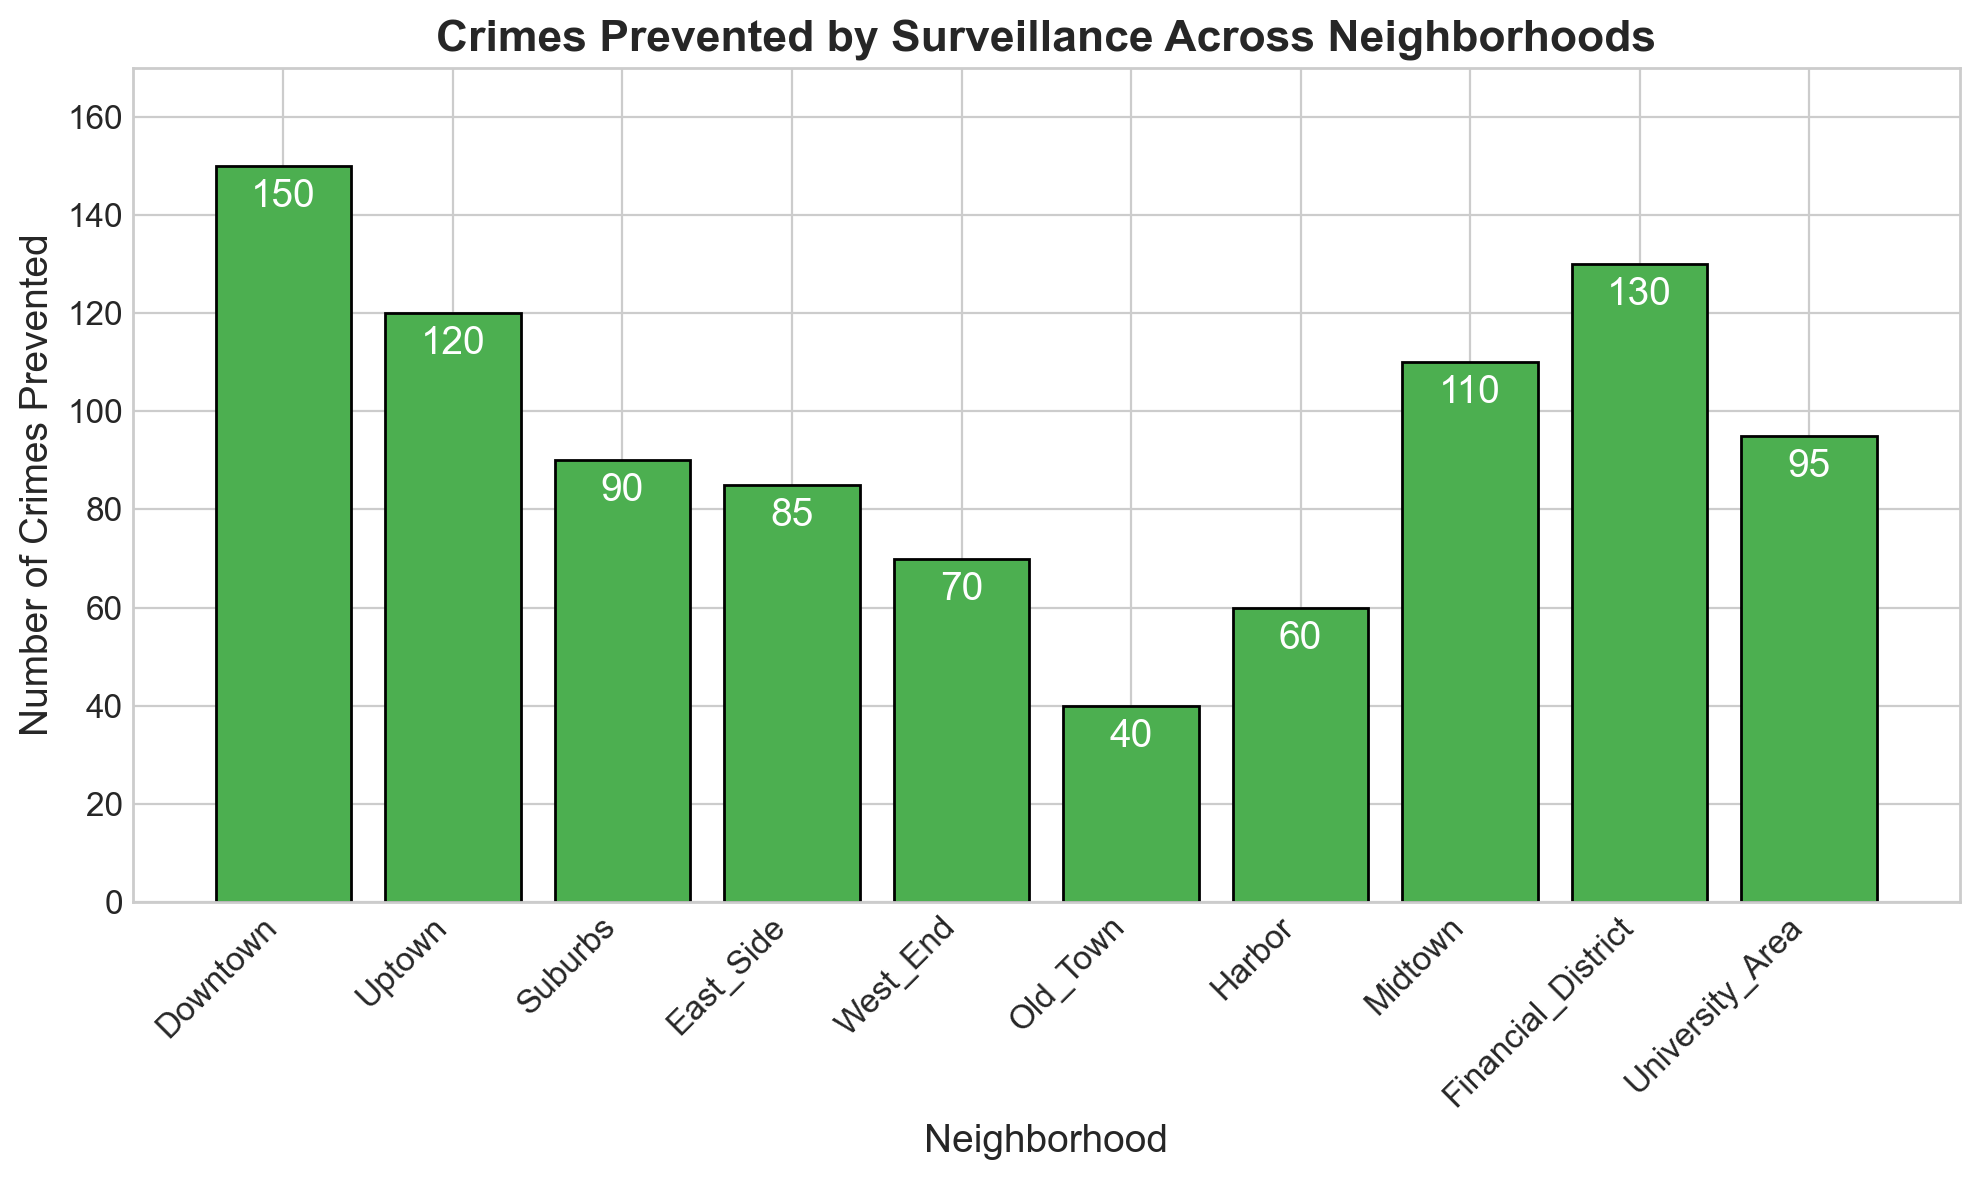What's the neighborhood with the highest number of crimes prevented? Look at the bar with the greatest height. The "Downtown" bar is the tallest, indicating the highest number of crimes prevented.
Answer: Downtown Which neighborhood prevented fewer crimes than the University Area but more than East Side? Identify the bars for University Area and East Side. University Area is 95, East Side is 85. Find bars between these values: Suburbs with 90 fits this range.
Answer: Suburbs How many total crimes were prevented in Uptown, Midtown, and Financial District combined? Add the values for these neighborhoods: Uptown (120), Midtown (110), Financial District (130). So, 120 + 110 + 130 = 360.
Answer: 360 What's the difference in the number of crimes prevented between Downtown and Old Town? Subtract the number for Old Town from Downtown: 150 - 40 = 110.
Answer: 110 Which neighborhood has exactly twice the number of crimes prevented as Old Town? Double the value for Old Town (40), so 40 x 2 = 80. Check the bars for a value of 80. None corresponds exactly; East Side is close but not exact at 85.
Answer: None What is the average number of crimes prevented across all neighborhoods? Add all values and divide by the number of neighborhoods: (150 + 120 + 90 + 85 + 70 + 40 + 60 + 110 + 130 + 95) / 10 = 950 / 10 = 95.
Answer: 95 If you sum the crimes prevented in the East Side and West End, do you get more or fewer crimes than Financial District? Add East Side (85) + West End (70) = 155. Compare this to Financial District (130). 155 is more than 130.
Answer: More Which three neighborhoods have the lowest number of crimes prevented? Look for the three shortest bars, identifying the neighborhoods associated with them: Old Town (40), Harbor (60), West End (70).
Answer: Old Town, Harbor, West End Is there any neighborhood where the number of crimes prevented is less than 50? Identify any bar with a height less than 50. Old Town has a value of 40.
Answer: Yes, Old Town What is the total number of crimes prevented by neighborhoods with a count over 100 each? Identify bars over 100: Downtown (150), Uptown (120), Midtown (110), Financial District (130). Sum these: 150 + 120 + 110 + 130 = 510.
Answer: 510 